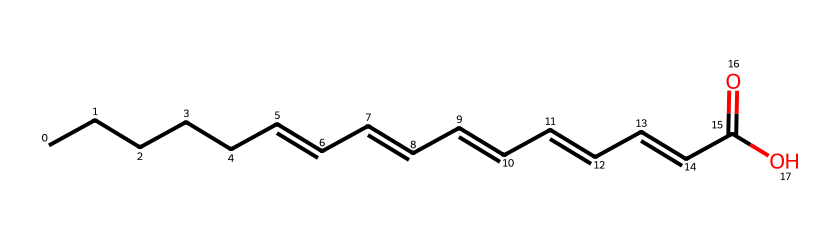What is the main functional group present in this chemical structure? The SMILES representation shows a carboxylic acid functional group at the end of the fatty acid chain (indicated by "C(=O)O"). This corresponds to the typical structure of fatty acids.
Answer: carboxylic acid How many double bonds are present in the structure? Upon examining the SMILES, there are three instances of "C=C" which indicate double bonds. Thus, the total count of double bonds in this omega-3 fatty acid is three.
Answer: three What is the total number of carbon atoms in this fatty acid? The SMILES shows a continuous chain of carbon atoms (C) where the count of carbon symbols indicates there are a total of 18 carbon atoms in the structure.
Answer: eighteen What type of lipid does this chemical represent? Given that this chemical structure is a long-chain fatty acid with multiple double bonds, it falls into the category of polyunsaturated fatty acids, particularly omega-3 fatty acids.
Answer: polyunsaturated fatty acid What is the role of the double bonds in this fatty acid? The presence of double bonds in the fatty acid chain introduces kinks in the structure, which prevent tight packing and contribute to fluidity, making these fats beneficial for cell membranes.
Answer: fluidity What would happen to the properties of this lipid if it were fully saturated? If this fatty acid were fully saturated (with single bonds only), it would have a straight-chain structure without kinks, leading to increased melting point and a more solid state at room temperature.
Answer: more solid 